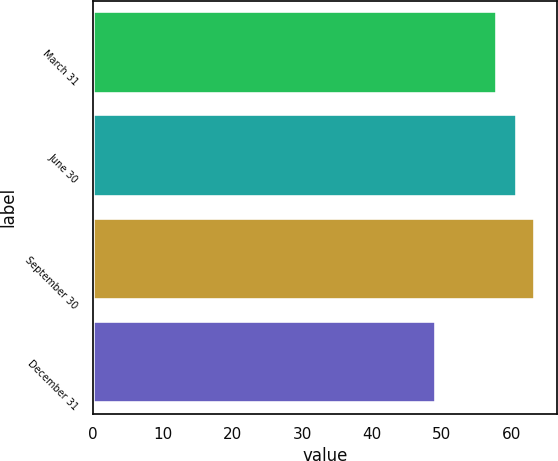Convert chart. <chart><loc_0><loc_0><loc_500><loc_500><bar_chart><fcel>March 31<fcel>June 30<fcel>September 30<fcel>December 31<nl><fcel>57.99<fcel>60.73<fcel>63.4<fcel>49.15<nl></chart> 